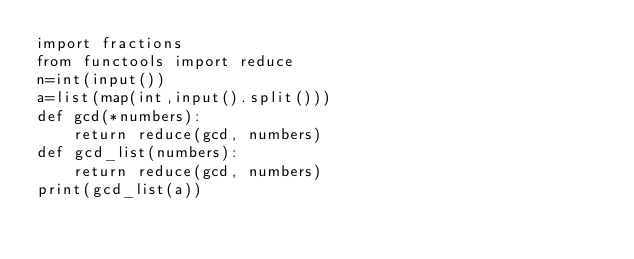Convert code to text. <code><loc_0><loc_0><loc_500><loc_500><_Python_>import fractions
from functools import reduce
n=int(input())
a=list(map(int,input().split()))
def gcd(*numbers):
    return reduce(gcd, numbers)
def gcd_list(numbers):
    return reduce(gcd, numbers)
print(gcd_list(a))</code> 